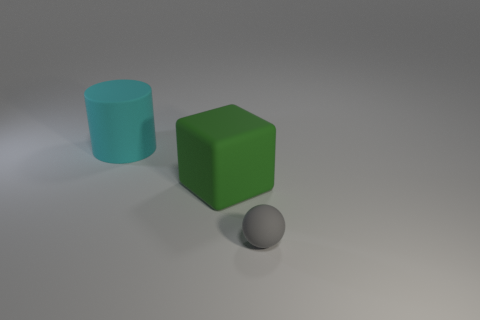Is there anything else that has the same size as the gray thing?
Your answer should be compact. No. What number of other things are there of the same size as the rubber block?
Your response must be concise. 1. Are there more small gray balls than large rubber objects?
Give a very brief answer. No. How many things are both in front of the cylinder and behind the small thing?
Your answer should be very brief. 1. What is the shape of the matte object that is on the right side of the big rubber object that is in front of the big matte object on the left side of the green matte thing?
Provide a short and direct response. Sphere. Is there any other thing that has the same shape as the big cyan thing?
Provide a short and direct response. No. How many blocks are either cyan rubber objects or tiny gray rubber things?
Your answer should be compact. 0. Is the color of the large thing in front of the cylinder the same as the rubber sphere?
Your answer should be compact. No. The object that is behind the big thing that is on the right side of the large thing that is to the left of the green thing is made of what material?
Your response must be concise. Rubber. Does the cyan matte cylinder have the same size as the ball?
Keep it short and to the point. No. 